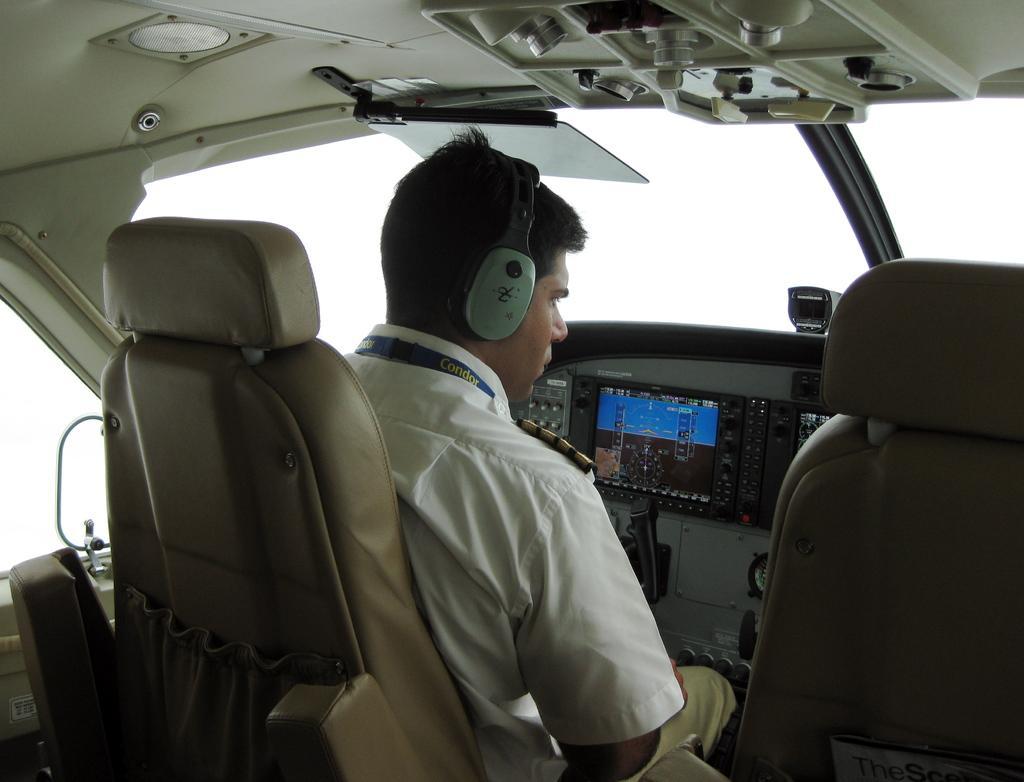In one or two sentences, can you explain what this image depicts? This is an inner view of an aircraft. On the left side, there is a person in a white color shirt, wearing a headset and sitting on a seat. On the right side, there is another seat. In the background, there are glass windows, a roof, a screen, buttons and other objects. 